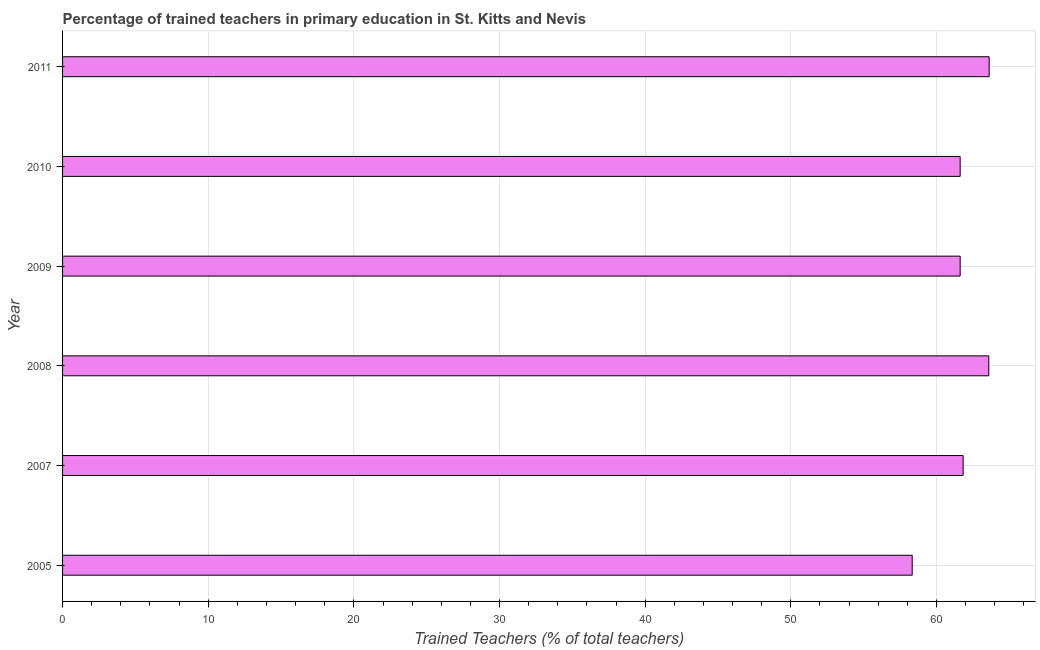Does the graph contain grids?
Make the answer very short. Yes. What is the title of the graph?
Your answer should be very brief. Percentage of trained teachers in primary education in St. Kitts and Nevis. What is the label or title of the X-axis?
Provide a short and direct response. Trained Teachers (% of total teachers). What is the label or title of the Y-axis?
Provide a short and direct response. Year. What is the percentage of trained teachers in 2008?
Ensure brevity in your answer.  63.59. Across all years, what is the maximum percentage of trained teachers?
Keep it short and to the point. 63.62. Across all years, what is the minimum percentage of trained teachers?
Ensure brevity in your answer.  58.33. In which year was the percentage of trained teachers maximum?
Make the answer very short. 2011. In which year was the percentage of trained teachers minimum?
Your response must be concise. 2005. What is the sum of the percentage of trained teachers?
Ensure brevity in your answer.  370.62. What is the difference between the percentage of trained teachers in 2005 and 2007?
Make the answer very short. -3.5. What is the average percentage of trained teachers per year?
Keep it short and to the point. 61.77. What is the median percentage of trained teachers?
Make the answer very short. 61.73. Is the difference between the percentage of trained teachers in 2007 and 2011 greater than the difference between any two years?
Provide a short and direct response. No. What is the difference between the highest and the second highest percentage of trained teachers?
Give a very brief answer. 0.03. Is the sum of the percentage of trained teachers in 2009 and 2011 greater than the maximum percentage of trained teachers across all years?
Offer a terse response. Yes. What is the difference between the highest and the lowest percentage of trained teachers?
Your answer should be compact. 5.28. In how many years, is the percentage of trained teachers greater than the average percentage of trained teachers taken over all years?
Provide a short and direct response. 3. How many years are there in the graph?
Give a very brief answer. 6. What is the difference between two consecutive major ticks on the X-axis?
Keep it short and to the point. 10. What is the Trained Teachers (% of total teachers) of 2005?
Ensure brevity in your answer.  58.33. What is the Trained Teachers (% of total teachers) in 2007?
Your answer should be compact. 61.83. What is the Trained Teachers (% of total teachers) of 2008?
Your response must be concise. 63.59. What is the Trained Teachers (% of total teachers) in 2009?
Give a very brief answer. 61.63. What is the Trained Teachers (% of total teachers) in 2010?
Your answer should be very brief. 61.63. What is the Trained Teachers (% of total teachers) of 2011?
Your answer should be compact. 63.62. What is the difference between the Trained Teachers (% of total teachers) in 2005 and 2007?
Make the answer very short. -3.49. What is the difference between the Trained Teachers (% of total teachers) in 2005 and 2008?
Provide a succinct answer. -5.26. What is the difference between the Trained Teachers (% of total teachers) in 2005 and 2009?
Make the answer very short. -3.29. What is the difference between the Trained Teachers (% of total teachers) in 2005 and 2010?
Your response must be concise. -3.29. What is the difference between the Trained Teachers (% of total teachers) in 2005 and 2011?
Your answer should be very brief. -5.28. What is the difference between the Trained Teachers (% of total teachers) in 2007 and 2008?
Offer a terse response. -1.76. What is the difference between the Trained Teachers (% of total teachers) in 2007 and 2009?
Your response must be concise. 0.2. What is the difference between the Trained Teachers (% of total teachers) in 2007 and 2010?
Offer a terse response. 0.2. What is the difference between the Trained Teachers (% of total teachers) in 2007 and 2011?
Your answer should be compact. -1.79. What is the difference between the Trained Teachers (% of total teachers) in 2008 and 2009?
Your answer should be compact. 1.97. What is the difference between the Trained Teachers (% of total teachers) in 2008 and 2010?
Your answer should be compact. 1.97. What is the difference between the Trained Teachers (% of total teachers) in 2008 and 2011?
Provide a succinct answer. -0.03. What is the difference between the Trained Teachers (% of total teachers) in 2009 and 2010?
Ensure brevity in your answer.  0. What is the difference between the Trained Teachers (% of total teachers) in 2009 and 2011?
Provide a succinct answer. -1.99. What is the difference between the Trained Teachers (% of total teachers) in 2010 and 2011?
Give a very brief answer. -1.99. What is the ratio of the Trained Teachers (% of total teachers) in 2005 to that in 2007?
Offer a very short reply. 0.94. What is the ratio of the Trained Teachers (% of total teachers) in 2005 to that in 2008?
Provide a succinct answer. 0.92. What is the ratio of the Trained Teachers (% of total teachers) in 2005 to that in 2009?
Your response must be concise. 0.95. What is the ratio of the Trained Teachers (% of total teachers) in 2005 to that in 2010?
Your answer should be very brief. 0.95. What is the ratio of the Trained Teachers (% of total teachers) in 2005 to that in 2011?
Give a very brief answer. 0.92. What is the ratio of the Trained Teachers (% of total teachers) in 2007 to that in 2008?
Offer a very short reply. 0.97. What is the ratio of the Trained Teachers (% of total teachers) in 2007 to that in 2011?
Ensure brevity in your answer.  0.97. What is the ratio of the Trained Teachers (% of total teachers) in 2008 to that in 2009?
Provide a short and direct response. 1.03. What is the ratio of the Trained Teachers (% of total teachers) in 2008 to that in 2010?
Offer a very short reply. 1.03. What is the ratio of the Trained Teachers (% of total teachers) in 2009 to that in 2010?
Your answer should be compact. 1. 